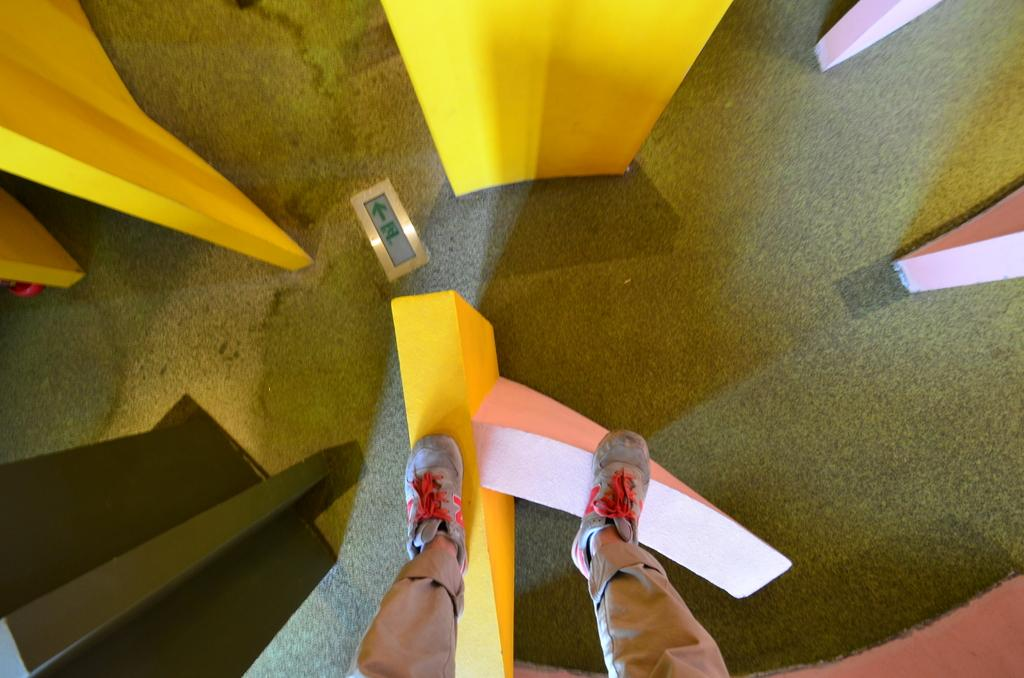What objects are present in the image? There are blocks in the image. What is the person in the image doing? A person is standing on a block in the image. What type of operation is being performed by the person in the image? There is no operation being performed in the image; the person is simply standing on a block. Can you describe the action of the person kissing another person in the image? There is no kissing or any other person present in the image; it only shows a person standing on a block. 